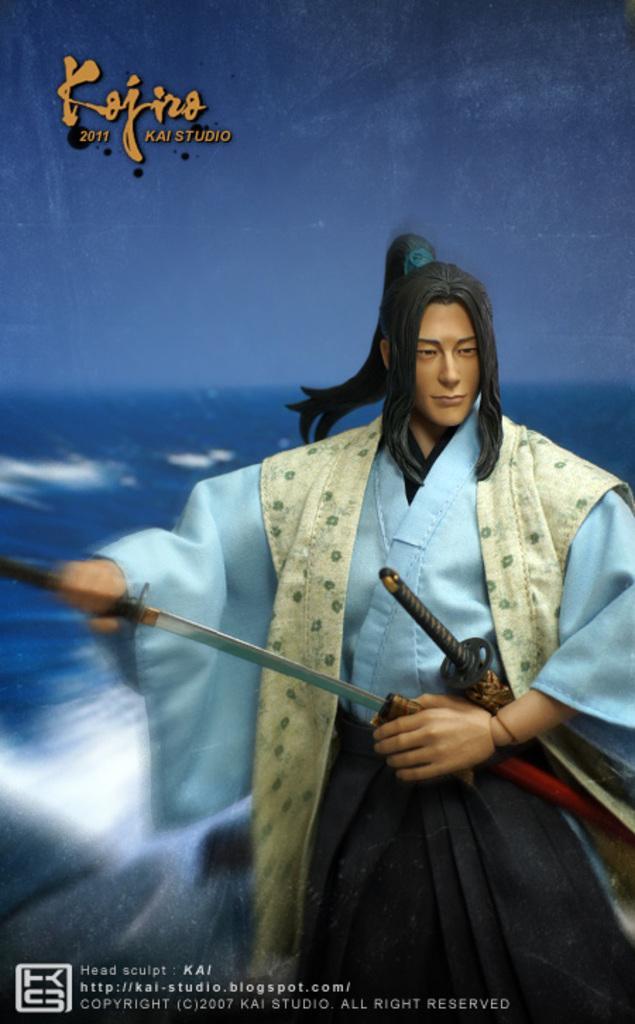How would you summarize this image in a sentence or two? In this image I can see a poster. There is some text on it. I can see a person holding swords. 